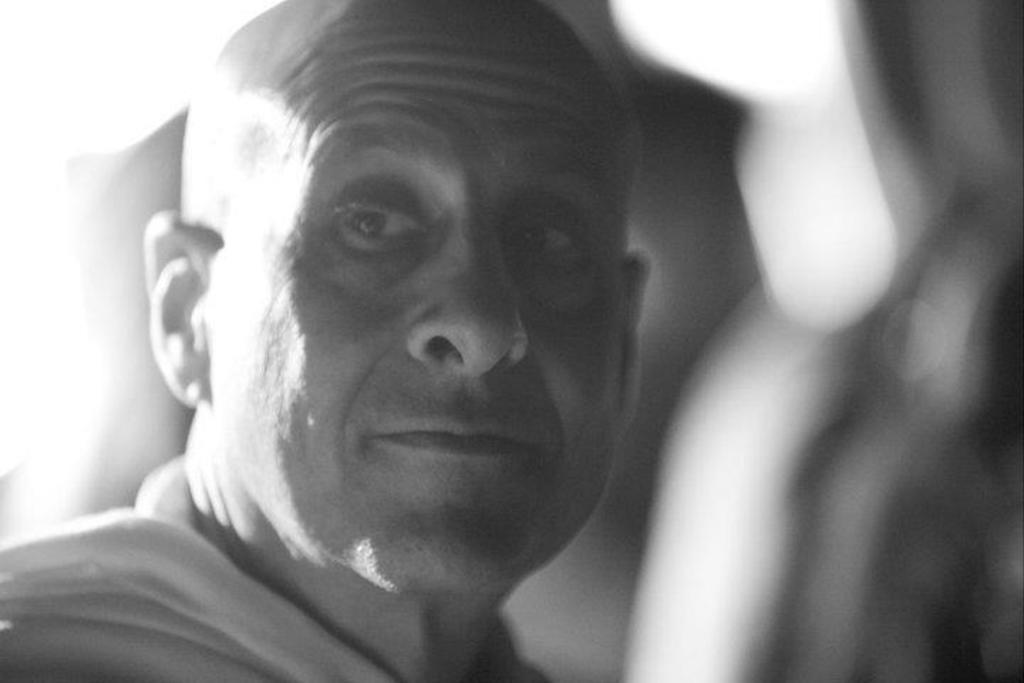What is the color scheme of the image? The image is black and white. Can you describe the main subject of the image? There is a person in the image. What can be observed about the background of the image? The background of the image is blurred. How many payments can be seen being made in the image? There is no payment or transaction depicted in the image. What type of flock is visible in the background of the image? There is no flock present in the image; the background is blurred. 